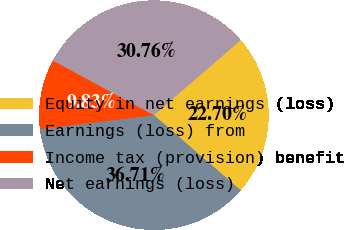Convert chart. <chart><loc_0><loc_0><loc_500><loc_500><pie_chart><fcel>Equity in net earnings (loss)<fcel>Earnings (loss) from<fcel>Income tax (provision) benefit<fcel>Net earnings (loss)<nl><fcel>22.7%<fcel>36.71%<fcel>9.83%<fcel>30.76%<nl></chart> 